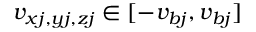<formula> <loc_0><loc_0><loc_500><loc_500>v _ { x j , y j , z j } \in [ - v _ { b j } , v _ { b j } ]</formula> 